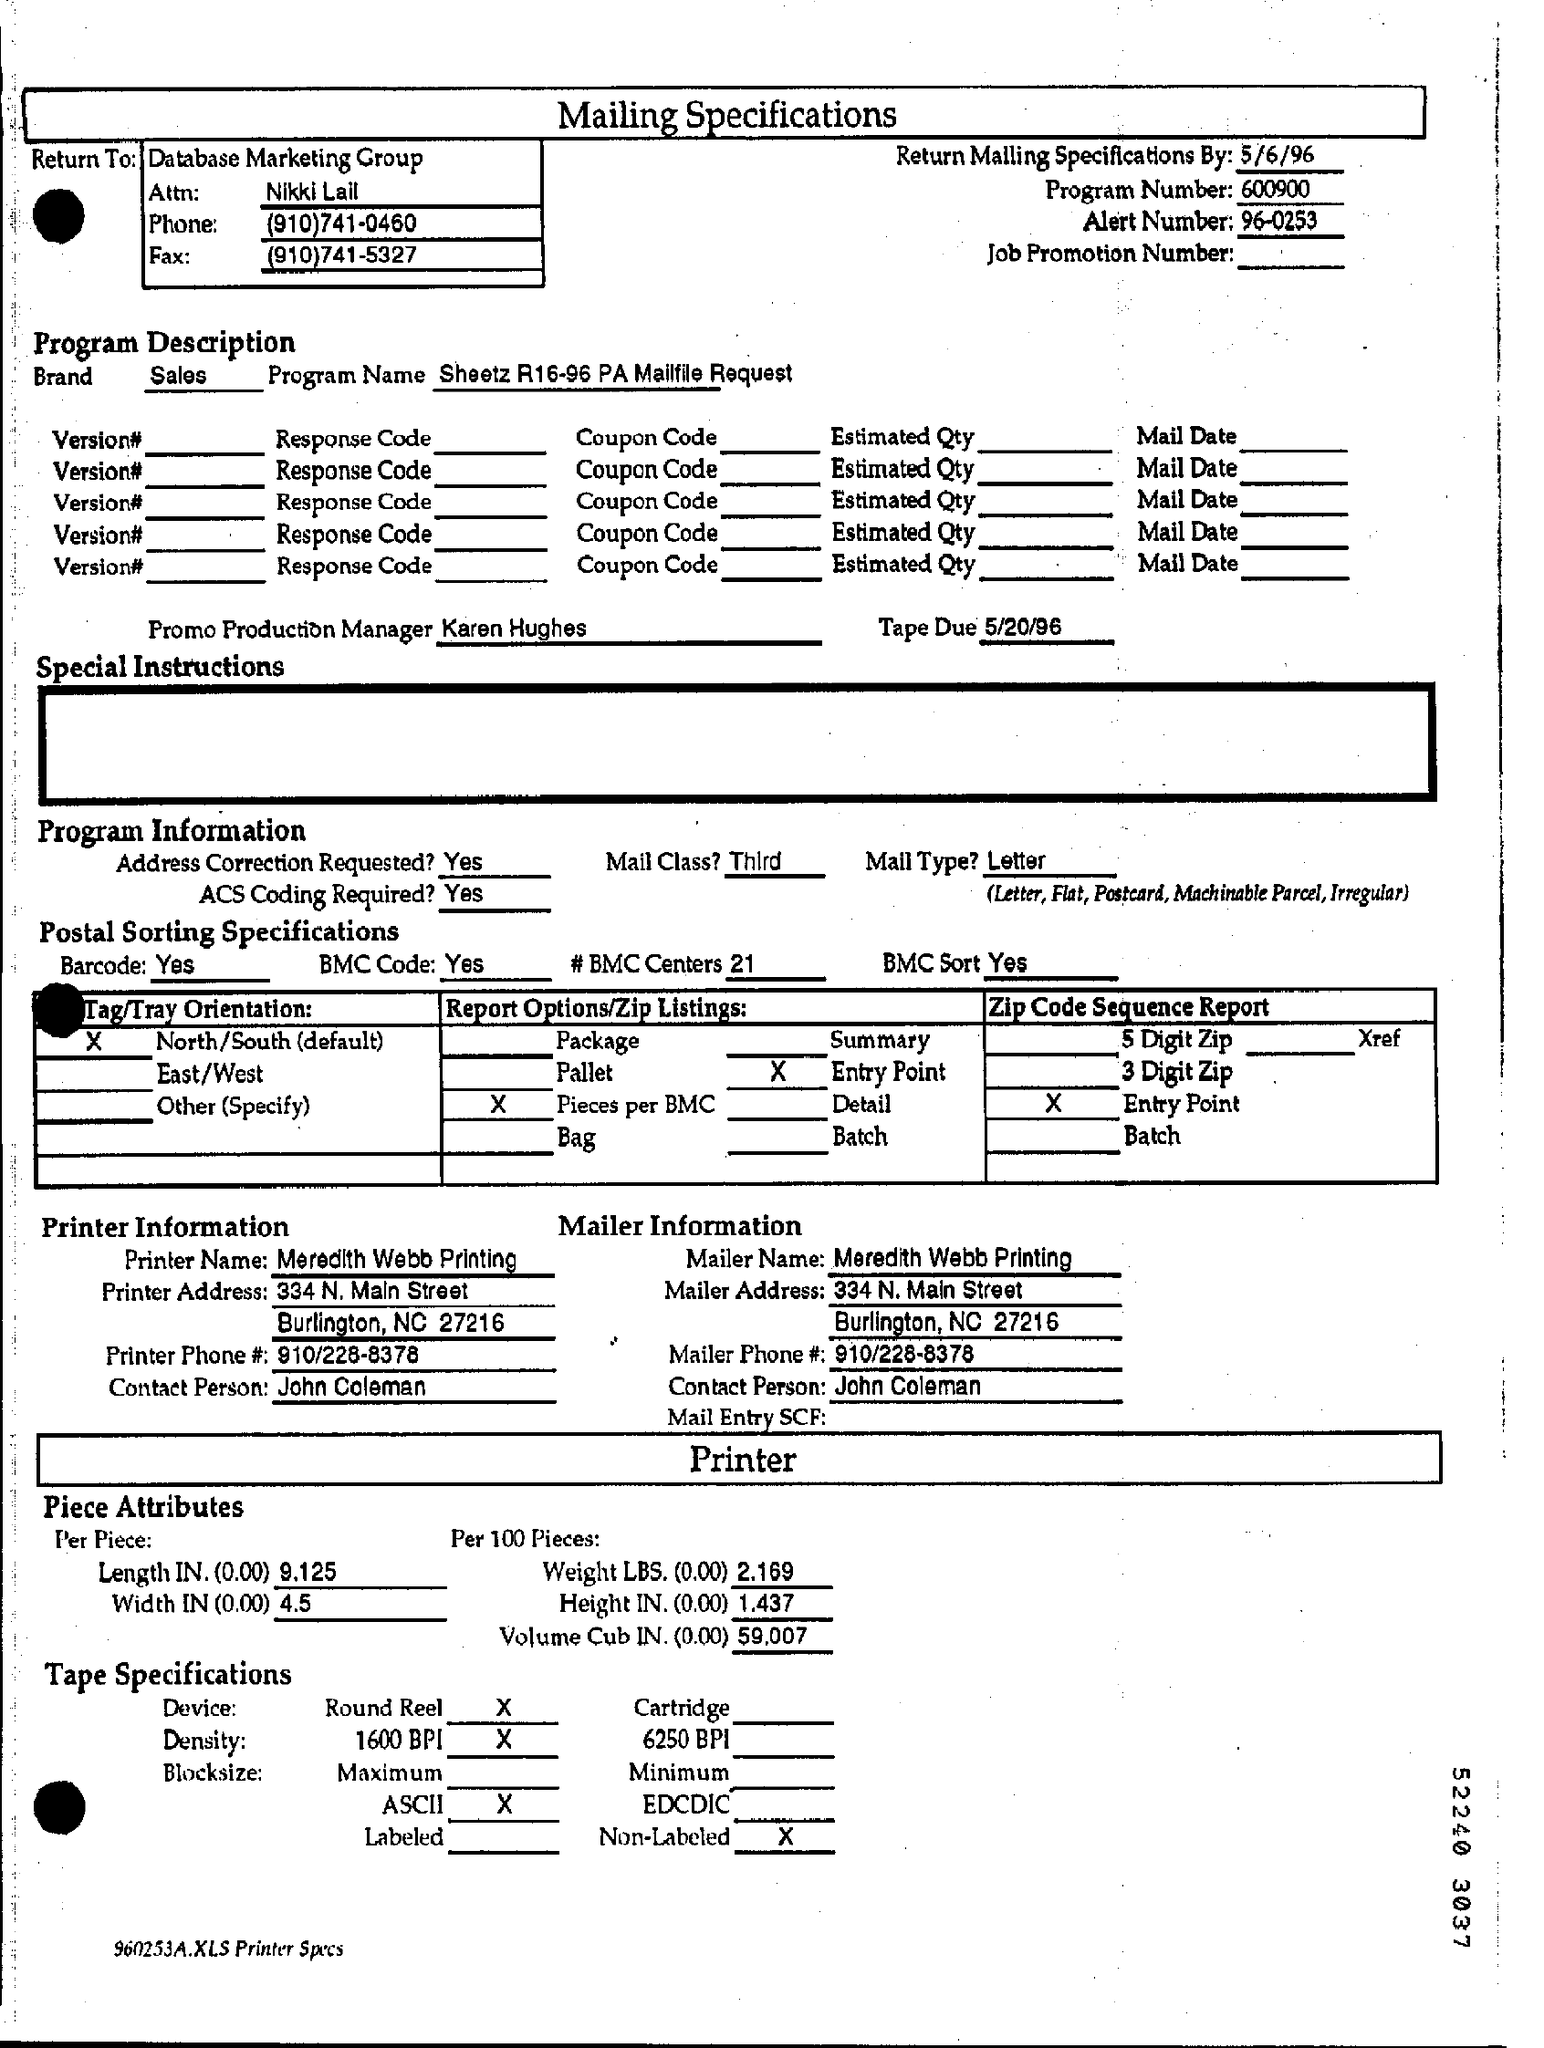Mention a couple of crucial points in this snapshot. The alert number is 96-0253. The program number is 600900... The date mentioned at the top of the document is 5/6/96. The mailing name is Meredith Webb Printing. The phone number is 910/228-8378. 